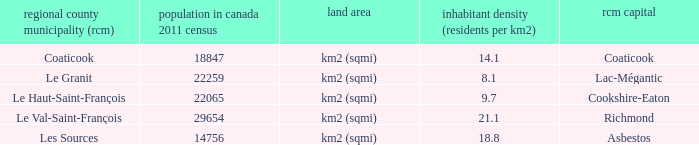What is the land area of the RCM having a density of 21.1? Km2 (sqmi). Could you help me parse every detail presented in this table? {'header': ['regional county municipality (rcm)', 'population in canada 2011 census', 'land area', 'inhabitant density (residents per km2)', 'rcm capital'], 'rows': [['Coaticook', '18847', 'km2 (sqmi)', '14.1', 'Coaticook'], ['Le Granit', '22259', 'km2 (sqmi)', '8.1', 'Lac-Mégantic'], ['Le Haut-Saint-François', '22065', 'km2 (sqmi)', '9.7', 'Cookshire-Eaton'], ['Le Val-Saint-François', '29654', 'km2 (sqmi)', '21.1', 'Richmond'], ['Les Sources', '14756', 'km2 (sqmi)', '18.8', 'Asbestos']]} 